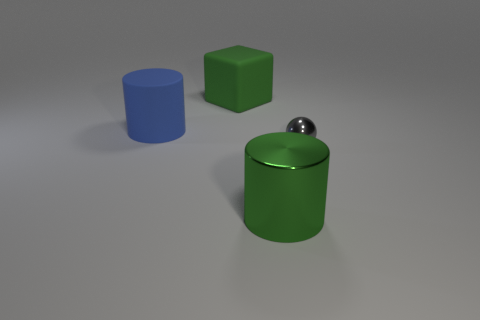What number of other objects are the same color as the big matte block?
Provide a short and direct response. 1. What color is the thing that is in front of the big blue matte object and behind the green metal thing?
Provide a short and direct response. Gray. How many cubes are tiny gray metal objects or blue objects?
Offer a terse response. 0. What number of green cylinders have the same size as the blue rubber object?
Offer a very short reply. 1. What number of large green cylinders are behind the big cylinder that is on the left side of the big green matte block?
Offer a very short reply. 0. What is the size of the thing that is behind the large green cylinder and in front of the blue object?
Your response must be concise. Small. Are there more big brown matte things than big metal objects?
Your answer should be very brief. No. Are there any big shiny cylinders that have the same color as the ball?
Keep it short and to the point. No. Do the green rubber block that is behind the blue object and the tiny gray ball have the same size?
Ensure brevity in your answer.  No. Is the number of yellow shiny cubes less than the number of tiny objects?
Provide a succinct answer. Yes. 